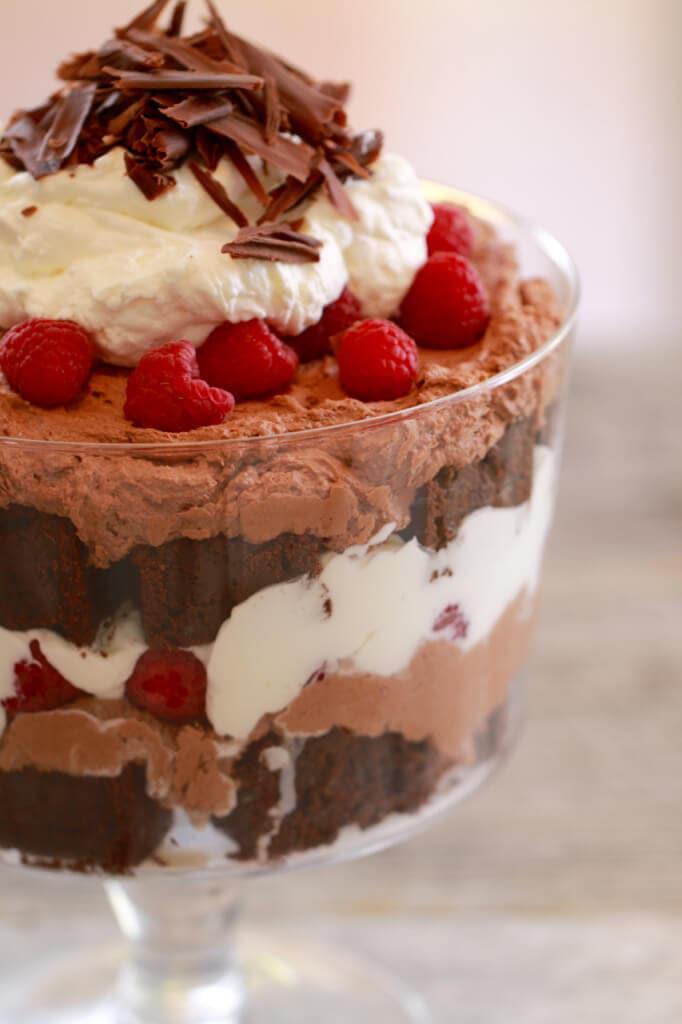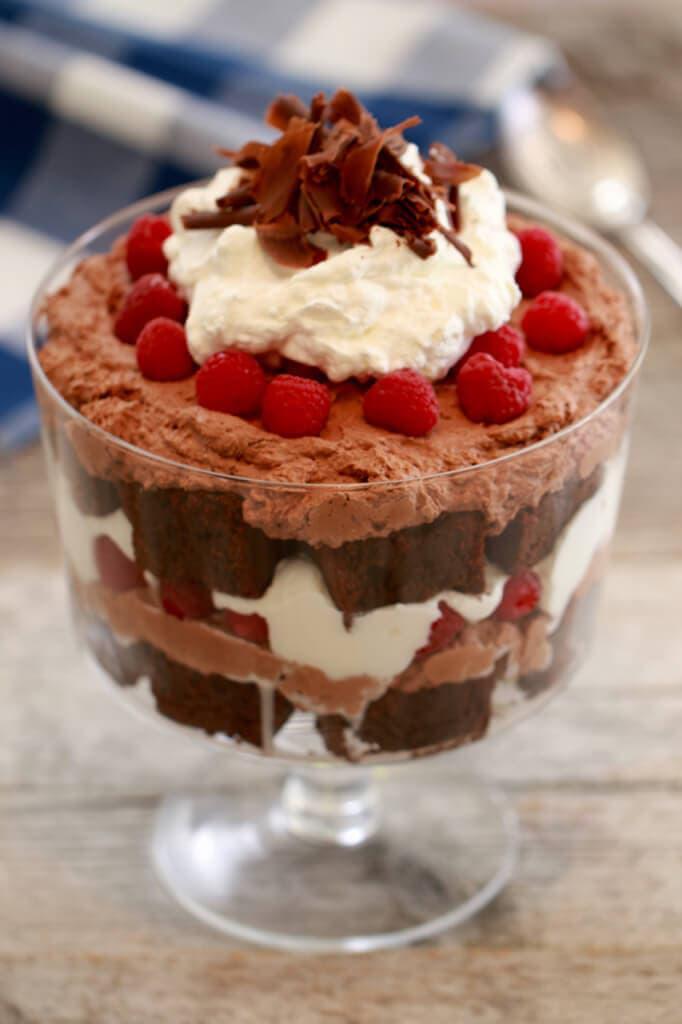The first image is the image on the left, the second image is the image on the right. Analyze the images presented: Is the assertion "At least one dessert is topped with brown shavings and served in a footed glass." valid? Answer yes or no. Yes. 